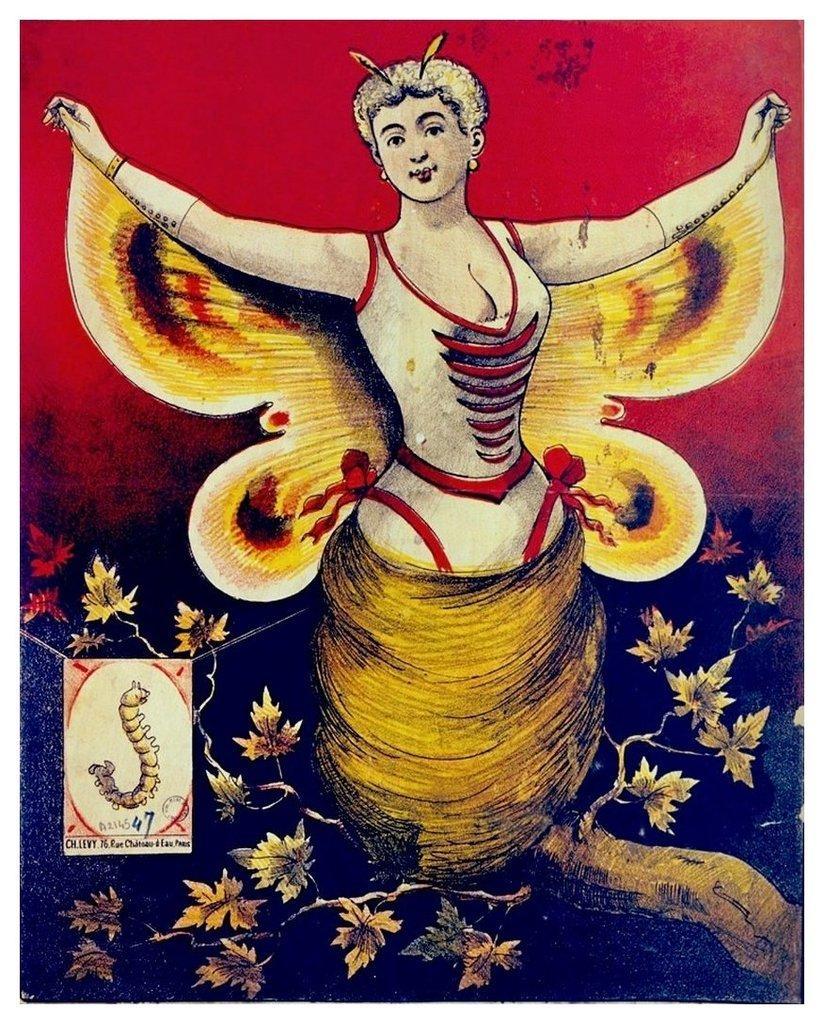How would you summarize this image in a sentence or two? This is a panting. In this image there is a painting of a woman with wings. At the bottom there is a tree and there is a painting of a caterpillar and there is a text. At the back there is red and black background. 